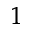<formula> <loc_0><loc_0><loc_500><loc_500>^ { 1 }</formula> 